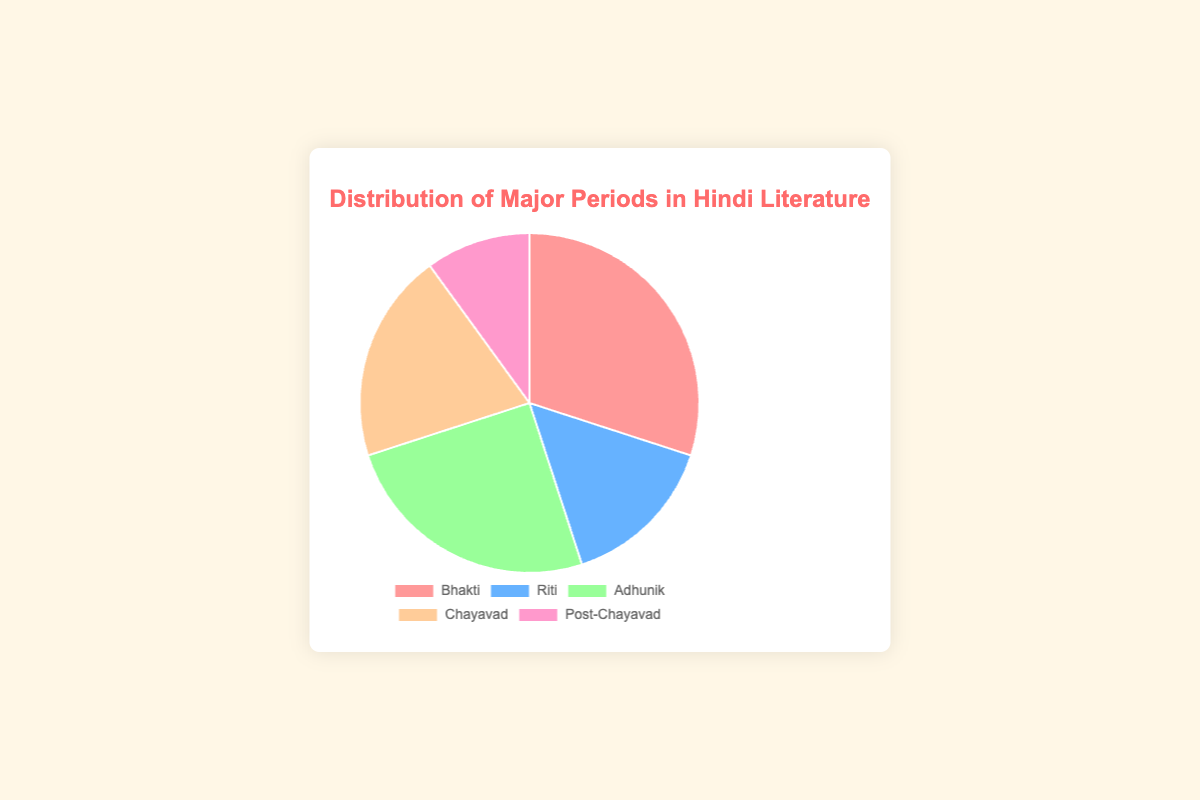What is the largest period in the distribution and what percentage does it occupy? The largest period can be identified by finding the data point with the highest value. Bhakti has the highest value with 30%, making it the largest period in the distribution.
Answer: Bhakti, 30% Which two periods sum up to the same percentage as the Bhakti period? By examining the data points of the periods, we see that Riti (15%) and Adhunik (25%) together total 40%, whereas Chayavad (20%) and Post-Chayavad (10%) together total 30%, the same as Bhakti.
Answer: Chayavad and Post-Chayavad What is the difference between the largest and smallest periods in the distribution? Bhakti is the largest at 30%, and Post-Chayavad is the smallest at 10%. Subtract the smallest from the largest to find the difference: 30% - 10% = 20%.
Answer: 20% Which period has the second highest percentage and what is its color in the chart? The period with the second highest value is identified by ranking the values. Adhunik comes after Bhakti with 25%, and its color is green on the pie chart.
Answer: Adhunik, green Which periods together constitute more than half of the distribution? By summing the data point values consecutively: Bhakti (30%) + Adhunik (25%) = 55%. These two periods together are more than half (50%).
Answer: Bhakti and Adhunik Are any two periods equal in their distribution percentage? A comparison of the given data points shows that no two periods have the same value: Bhakti (30%), Riti (15%), Adhunik (25%), Chayavad (20%), Post-Chayavad (10%).
Answer: No What is the average percentage of all the periods combined? Sum all the period values (30% + 15% + 25% + 20% + 10% = 100%) and then divide by the number of periods, which is 5. Average = 100% / 5 = 20%.
Answer: 20% Which period is represented by the color blue and what percentage of the distribution does it occupy? Visual examination identifies the period corresponding to blue, which is Riti, and it occupies 15% of the distribution.
Answer: Riti, 15% If the percentages of Chayavad and Post-Chayavad are combined, do they equal the percentage of Adhunik? Sum the Chayavad (20%) and Post-Chayavad (10%) values. 20% + 10% = 30%. Compare this sum to Adhunik (25%). They do not equal each other.
Answer: No What is the total percentage occupied by periods other than Bhakti? By summing the values of periods excluding Bhakti: Riti (15%) + Adhunik (25%) + Chayavad (20%) + Post-Chayavad (10%) = 70%.
Answer: 70% 